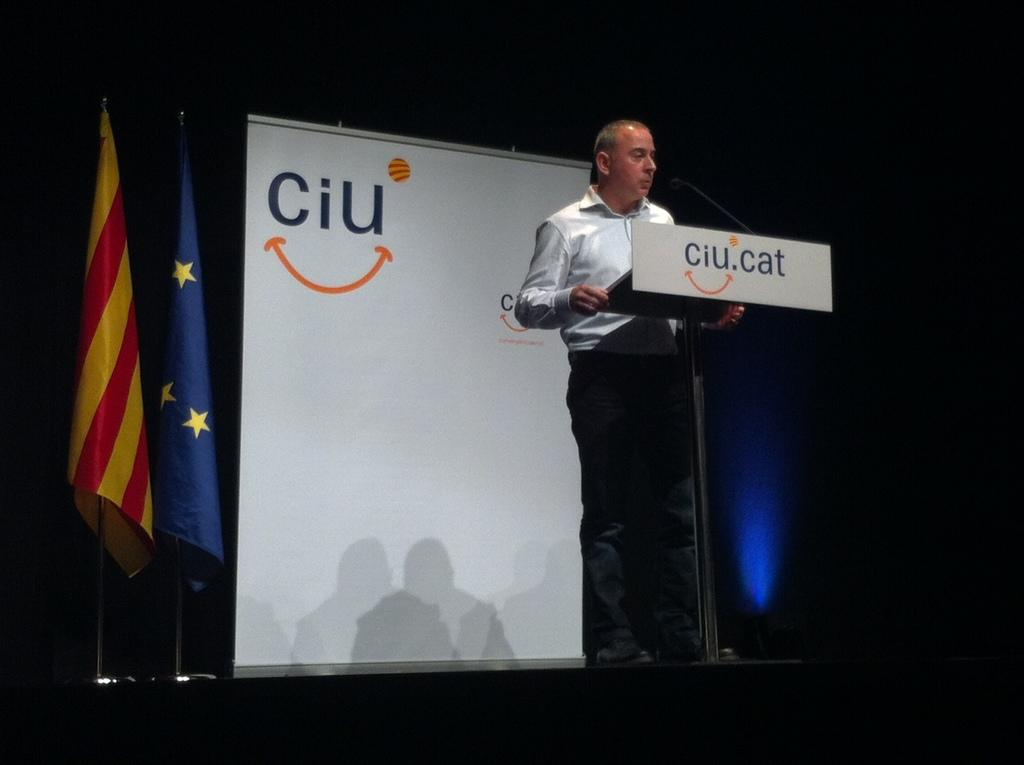What is the main subject of the image? There is a man standing in the image. What is located near the man? There is a stand near the man. What can be seen in the background of the image? There are flags on poles in the background of the image. What is the purpose of the board with writing in the image? The board with writing may contain information or advertisements. How many beds are visible in the image? There are no beds present in the image. What type of sorting is being done by the man in the image? The man is not sorting anything in the image; he is simply standing. 